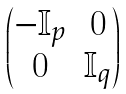<formula> <loc_0><loc_0><loc_500><loc_500>\begin{pmatrix} - \mathbb { I } _ { p } & 0 \\ 0 & \mathbb { I } _ { q } \end{pmatrix}</formula> 